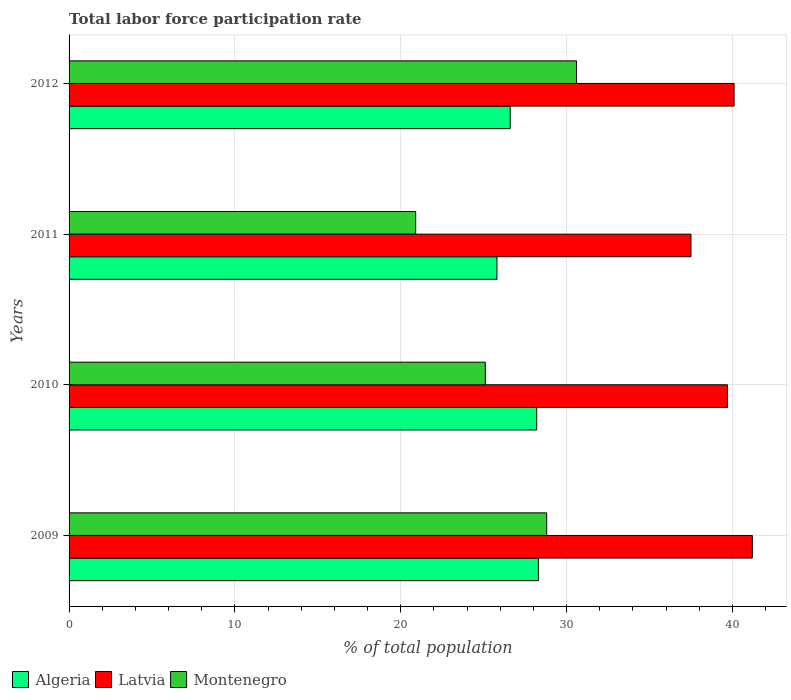How many different coloured bars are there?
Your answer should be compact. 3. Are the number of bars on each tick of the Y-axis equal?
Give a very brief answer. Yes. In how many cases, is the number of bars for a given year not equal to the number of legend labels?
Ensure brevity in your answer.  0. What is the total labor force participation rate in Latvia in 2009?
Keep it short and to the point. 41.2. Across all years, what is the maximum total labor force participation rate in Latvia?
Your answer should be very brief. 41.2. Across all years, what is the minimum total labor force participation rate in Algeria?
Ensure brevity in your answer.  25.8. In which year was the total labor force participation rate in Montenegro minimum?
Give a very brief answer. 2011. What is the total total labor force participation rate in Algeria in the graph?
Your answer should be very brief. 108.9. What is the difference between the total labor force participation rate in Algeria in 2011 and that in 2012?
Keep it short and to the point. -0.8. What is the difference between the total labor force participation rate in Algeria in 2009 and the total labor force participation rate in Latvia in 2011?
Give a very brief answer. -9.2. What is the average total labor force participation rate in Montenegro per year?
Your response must be concise. 26.35. In the year 2009, what is the difference between the total labor force participation rate in Latvia and total labor force participation rate in Montenegro?
Offer a terse response. 12.4. In how many years, is the total labor force participation rate in Montenegro greater than 6 %?
Provide a short and direct response. 4. What is the ratio of the total labor force participation rate in Algeria in 2009 to that in 2011?
Your answer should be compact. 1.1. Is the difference between the total labor force participation rate in Latvia in 2009 and 2012 greater than the difference between the total labor force participation rate in Montenegro in 2009 and 2012?
Offer a terse response. Yes. What is the difference between the highest and the second highest total labor force participation rate in Latvia?
Provide a succinct answer. 1.1. Is the sum of the total labor force participation rate in Algeria in 2009 and 2010 greater than the maximum total labor force participation rate in Latvia across all years?
Your answer should be compact. Yes. What does the 3rd bar from the top in 2011 represents?
Your answer should be very brief. Algeria. What does the 3rd bar from the bottom in 2012 represents?
Your answer should be compact. Montenegro. Is it the case that in every year, the sum of the total labor force participation rate in Montenegro and total labor force participation rate in Latvia is greater than the total labor force participation rate in Algeria?
Your answer should be compact. Yes. How many bars are there?
Offer a very short reply. 12. Are all the bars in the graph horizontal?
Your answer should be very brief. Yes. How many years are there in the graph?
Keep it short and to the point. 4. What is the difference between two consecutive major ticks on the X-axis?
Your response must be concise. 10. Are the values on the major ticks of X-axis written in scientific E-notation?
Make the answer very short. No. Where does the legend appear in the graph?
Ensure brevity in your answer.  Bottom left. What is the title of the graph?
Ensure brevity in your answer.  Total labor force participation rate. Does "Israel" appear as one of the legend labels in the graph?
Your answer should be compact. No. What is the label or title of the X-axis?
Your answer should be compact. % of total population. What is the label or title of the Y-axis?
Make the answer very short. Years. What is the % of total population of Algeria in 2009?
Your answer should be compact. 28.3. What is the % of total population in Latvia in 2009?
Your answer should be very brief. 41.2. What is the % of total population of Montenegro in 2009?
Offer a terse response. 28.8. What is the % of total population of Algeria in 2010?
Provide a short and direct response. 28.2. What is the % of total population of Latvia in 2010?
Ensure brevity in your answer.  39.7. What is the % of total population of Montenegro in 2010?
Your answer should be compact. 25.1. What is the % of total population in Algeria in 2011?
Provide a short and direct response. 25.8. What is the % of total population of Latvia in 2011?
Your answer should be compact. 37.5. What is the % of total population of Montenegro in 2011?
Ensure brevity in your answer.  20.9. What is the % of total population of Algeria in 2012?
Your answer should be very brief. 26.6. What is the % of total population in Latvia in 2012?
Your response must be concise. 40.1. What is the % of total population of Montenegro in 2012?
Make the answer very short. 30.6. Across all years, what is the maximum % of total population in Algeria?
Provide a short and direct response. 28.3. Across all years, what is the maximum % of total population in Latvia?
Your response must be concise. 41.2. Across all years, what is the maximum % of total population of Montenegro?
Ensure brevity in your answer.  30.6. Across all years, what is the minimum % of total population of Algeria?
Make the answer very short. 25.8. Across all years, what is the minimum % of total population in Latvia?
Give a very brief answer. 37.5. Across all years, what is the minimum % of total population of Montenegro?
Your answer should be very brief. 20.9. What is the total % of total population in Algeria in the graph?
Ensure brevity in your answer.  108.9. What is the total % of total population of Latvia in the graph?
Provide a short and direct response. 158.5. What is the total % of total population of Montenegro in the graph?
Offer a terse response. 105.4. What is the difference between the % of total population of Algeria in 2009 and that in 2010?
Ensure brevity in your answer.  0.1. What is the difference between the % of total population of Algeria in 2009 and that in 2012?
Your answer should be very brief. 1.7. What is the difference between the % of total population in Latvia in 2009 and that in 2012?
Ensure brevity in your answer.  1.1. What is the difference between the % of total population in Montenegro in 2009 and that in 2012?
Your answer should be compact. -1.8. What is the difference between the % of total population in Algeria in 2010 and that in 2011?
Your answer should be compact. 2.4. What is the difference between the % of total population in Montenegro in 2010 and that in 2011?
Ensure brevity in your answer.  4.2. What is the difference between the % of total population of Montenegro in 2010 and that in 2012?
Offer a terse response. -5.5. What is the difference between the % of total population of Algeria in 2011 and that in 2012?
Your response must be concise. -0.8. What is the difference between the % of total population of Latvia in 2011 and that in 2012?
Keep it short and to the point. -2.6. What is the difference between the % of total population in Montenegro in 2011 and that in 2012?
Your answer should be compact. -9.7. What is the difference between the % of total population in Algeria in 2009 and the % of total population in Montenegro in 2010?
Give a very brief answer. 3.2. What is the difference between the % of total population of Latvia in 2009 and the % of total population of Montenegro in 2010?
Ensure brevity in your answer.  16.1. What is the difference between the % of total population of Algeria in 2009 and the % of total population of Latvia in 2011?
Give a very brief answer. -9.2. What is the difference between the % of total population of Algeria in 2009 and the % of total population of Montenegro in 2011?
Offer a very short reply. 7.4. What is the difference between the % of total population of Latvia in 2009 and the % of total population of Montenegro in 2011?
Provide a succinct answer. 20.3. What is the difference between the % of total population of Algeria in 2009 and the % of total population of Latvia in 2012?
Give a very brief answer. -11.8. What is the difference between the % of total population in Latvia in 2009 and the % of total population in Montenegro in 2012?
Provide a succinct answer. 10.6. What is the difference between the % of total population of Algeria in 2010 and the % of total population of Latvia in 2011?
Give a very brief answer. -9.3. What is the difference between the % of total population of Algeria in 2010 and the % of total population of Montenegro in 2011?
Offer a terse response. 7.3. What is the difference between the % of total population of Latvia in 2010 and the % of total population of Montenegro in 2012?
Offer a terse response. 9.1. What is the difference between the % of total population in Algeria in 2011 and the % of total population in Latvia in 2012?
Your answer should be compact. -14.3. What is the average % of total population in Algeria per year?
Give a very brief answer. 27.23. What is the average % of total population in Latvia per year?
Make the answer very short. 39.62. What is the average % of total population in Montenegro per year?
Provide a short and direct response. 26.35. In the year 2009, what is the difference between the % of total population in Algeria and % of total population in Montenegro?
Ensure brevity in your answer.  -0.5. In the year 2010, what is the difference between the % of total population in Algeria and % of total population in Latvia?
Your answer should be compact. -11.5. In the year 2011, what is the difference between the % of total population in Algeria and % of total population in Montenegro?
Ensure brevity in your answer.  4.9. In the year 2011, what is the difference between the % of total population of Latvia and % of total population of Montenegro?
Keep it short and to the point. 16.6. What is the ratio of the % of total population in Latvia in 2009 to that in 2010?
Make the answer very short. 1.04. What is the ratio of the % of total population of Montenegro in 2009 to that in 2010?
Give a very brief answer. 1.15. What is the ratio of the % of total population of Algeria in 2009 to that in 2011?
Give a very brief answer. 1.1. What is the ratio of the % of total population in Latvia in 2009 to that in 2011?
Your answer should be compact. 1.1. What is the ratio of the % of total population in Montenegro in 2009 to that in 2011?
Provide a short and direct response. 1.38. What is the ratio of the % of total population in Algeria in 2009 to that in 2012?
Offer a terse response. 1.06. What is the ratio of the % of total population of Latvia in 2009 to that in 2012?
Ensure brevity in your answer.  1.03. What is the ratio of the % of total population in Algeria in 2010 to that in 2011?
Your response must be concise. 1.09. What is the ratio of the % of total population in Latvia in 2010 to that in 2011?
Your answer should be very brief. 1.06. What is the ratio of the % of total population in Montenegro in 2010 to that in 2011?
Give a very brief answer. 1.2. What is the ratio of the % of total population in Algeria in 2010 to that in 2012?
Make the answer very short. 1.06. What is the ratio of the % of total population of Latvia in 2010 to that in 2012?
Your answer should be compact. 0.99. What is the ratio of the % of total population of Montenegro in 2010 to that in 2012?
Offer a terse response. 0.82. What is the ratio of the % of total population in Algeria in 2011 to that in 2012?
Keep it short and to the point. 0.97. What is the ratio of the % of total population of Latvia in 2011 to that in 2012?
Your response must be concise. 0.94. What is the ratio of the % of total population in Montenegro in 2011 to that in 2012?
Provide a succinct answer. 0.68. What is the difference between the highest and the second highest % of total population of Montenegro?
Give a very brief answer. 1.8. What is the difference between the highest and the lowest % of total population of Algeria?
Make the answer very short. 2.5. What is the difference between the highest and the lowest % of total population in Latvia?
Your response must be concise. 3.7. What is the difference between the highest and the lowest % of total population of Montenegro?
Your response must be concise. 9.7. 